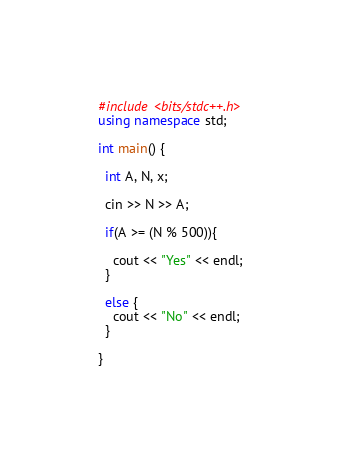Convert code to text. <code><loc_0><loc_0><loc_500><loc_500><_C++_>#include <bits/stdc++.h>
using namespace std;

int main() {
  
  int A, N, x;
  
  cin >> N >> A;

  if(A >= (N % 500)){

    cout << "Yes" << endl;
  }

  else {
    cout << "No" << endl;
  }

}</code> 